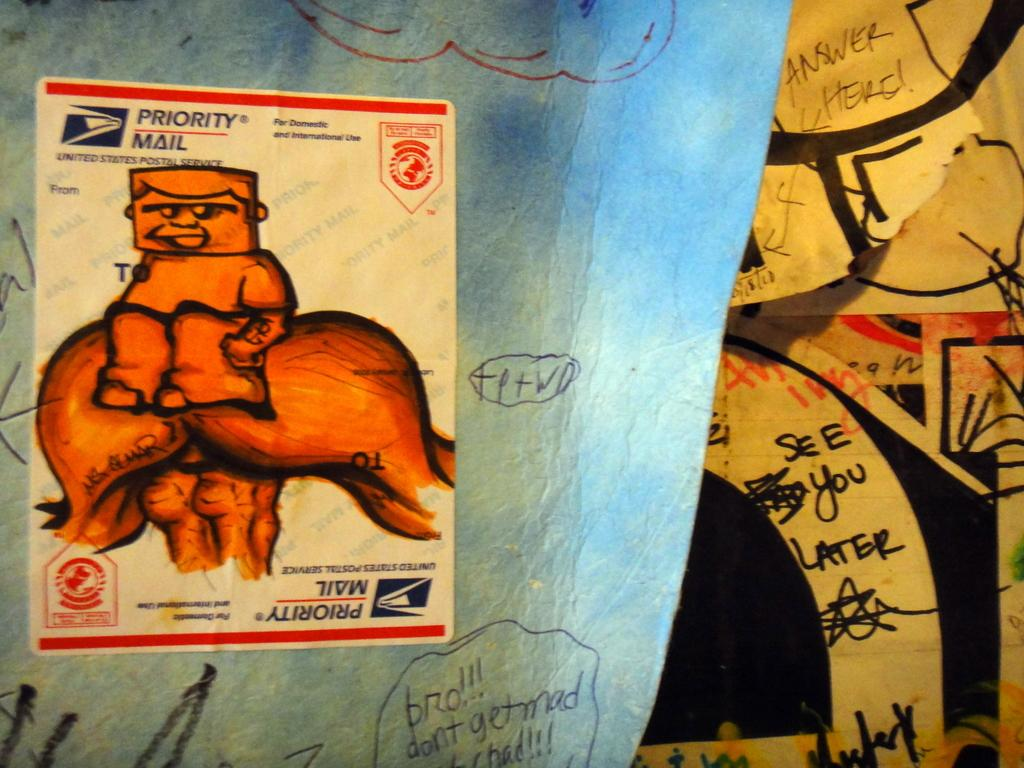What is present in the image that contains both images and text? There is a poster in the image that contains images and text. What type of rod can be seen rolling across the poster in the image? There is no rod or rolling action present in the image; the poster contains images and text only. 